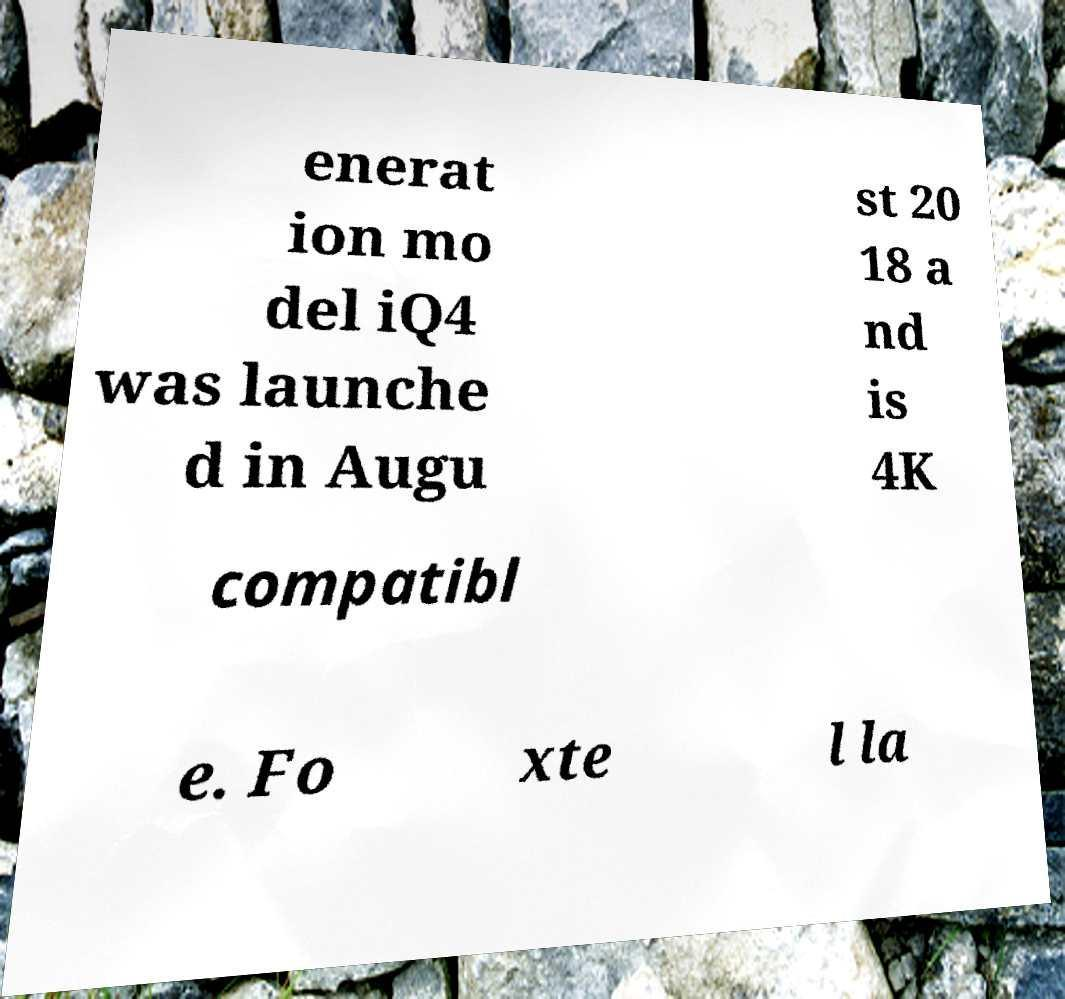Please read and relay the text visible in this image. What does it say? enerat ion mo del iQ4 was launche d in Augu st 20 18 a nd is 4K compatibl e. Fo xte l la 